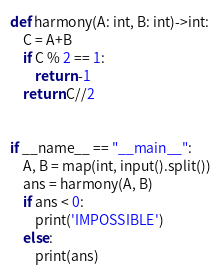<code> <loc_0><loc_0><loc_500><loc_500><_Python_>def harmony(A: int, B: int)->int:
    C = A+B
    if C % 2 == 1:
        return -1
    return C//2


if __name__ == "__main__":
    A, B = map(int, input().split())
    ans = harmony(A, B)
    if ans < 0:
        print('IMPOSSIBLE')
    else:
        print(ans)
</code> 